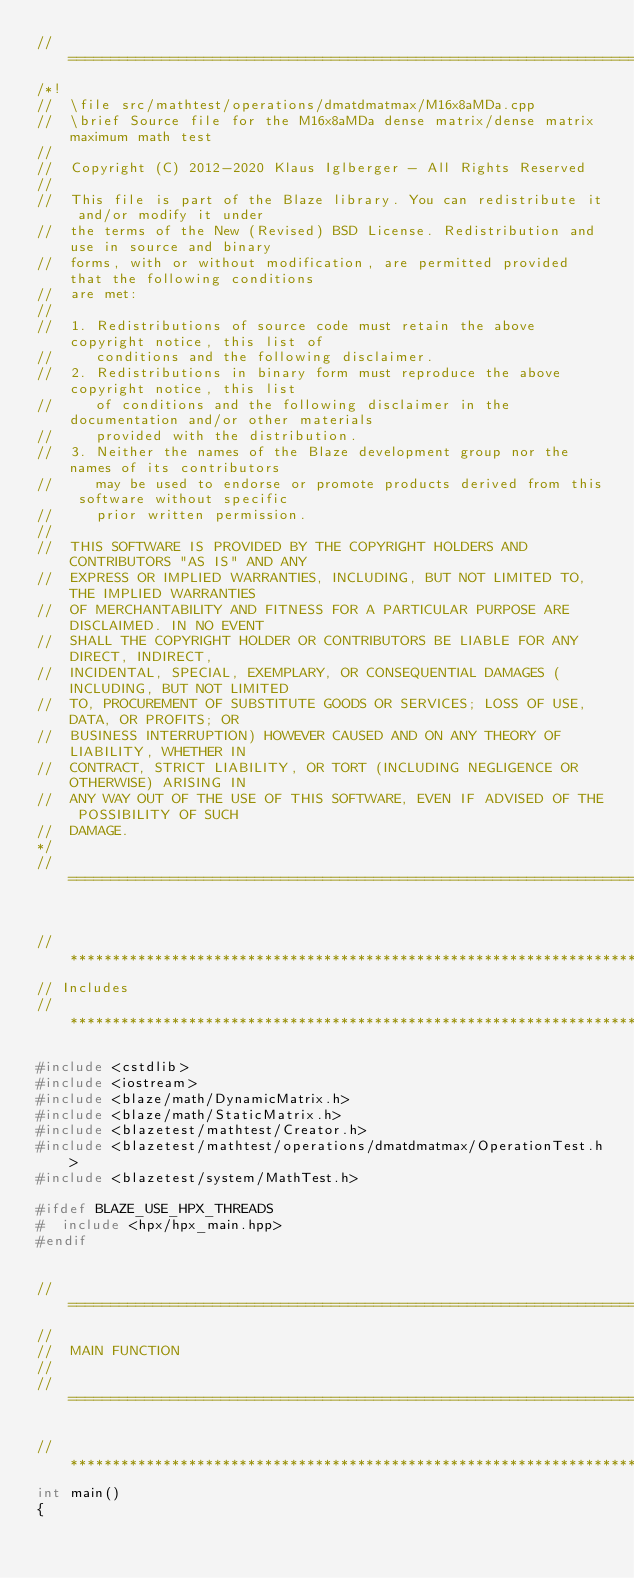<code> <loc_0><loc_0><loc_500><loc_500><_C++_>//=================================================================================================
/*!
//  \file src/mathtest/operations/dmatdmatmax/M16x8aMDa.cpp
//  \brief Source file for the M16x8aMDa dense matrix/dense matrix maximum math test
//
//  Copyright (C) 2012-2020 Klaus Iglberger - All Rights Reserved
//
//  This file is part of the Blaze library. You can redistribute it and/or modify it under
//  the terms of the New (Revised) BSD License. Redistribution and use in source and binary
//  forms, with or without modification, are permitted provided that the following conditions
//  are met:
//
//  1. Redistributions of source code must retain the above copyright notice, this list of
//     conditions and the following disclaimer.
//  2. Redistributions in binary form must reproduce the above copyright notice, this list
//     of conditions and the following disclaimer in the documentation and/or other materials
//     provided with the distribution.
//  3. Neither the names of the Blaze development group nor the names of its contributors
//     may be used to endorse or promote products derived from this software without specific
//     prior written permission.
//
//  THIS SOFTWARE IS PROVIDED BY THE COPYRIGHT HOLDERS AND CONTRIBUTORS "AS IS" AND ANY
//  EXPRESS OR IMPLIED WARRANTIES, INCLUDING, BUT NOT LIMITED TO, THE IMPLIED WARRANTIES
//  OF MERCHANTABILITY AND FITNESS FOR A PARTICULAR PURPOSE ARE DISCLAIMED. IN NO EVENT
//  SHALL THE COPYRIGHT HOLDER OR CONTRIBUTORS BE LIABLE FOR ANY DIRECT, INDIRECT,
//  INCIDENTAL, SPECIAL, EXEMPLARY, OR CONSEQUENTIAL DAMAGES (INCLUDING, BUT NOT LIMITED
//  TO, PROCUREMENT OF SUBSTITUTE GOODS OR SERVICES; LOSS OF USE, DATA, OR PROFITS; OR
//  BUSINESS INTERRUPTION) HOWEVER CAUSED AND ON ANY THEORY OF LIABILITY, WHETHER IN
//  CONTRACT, STRICT LIABILITY, OR TORT (INCLUDING NEGLIGENCE OR OTHERWISE) ARISING IN
//  ANY WAY OUT OF THE USE OF THIS SOFTWARE, EVEN IF ADVISED OF THE POSSIBILITY OF SUCH
//  DAMAGE.
*/
//=================================================================================================


//*************************************************************************************************
// Includes
//*************************************************************************************************

#include <cstdlib>
#include <iostream>
#include <blaze/math/DynamicMatrix.h>
#include <blaze/math/StaticMatrix.h>
#include <blazetest/mathtest/Creator.h>
#include <blazetest/mathtest/operations/dmatdmatmax/OperationTest.h>
#include <blazetest/system/MathTest.h>

#ifdef BLAZE_USE_HPX_THREADS
#  include <hpx/hpx_main.hpp>
#endif


//=================================================================================================
//
//  MAIN FUNCTION
//
//=================================================================================================

//*************************************************************************************************
int main()
{</code> 